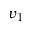Convert formula to latex. <formula><loc_0><loc_0><loc_500><loc_500>v _ { 1 }</formula> 